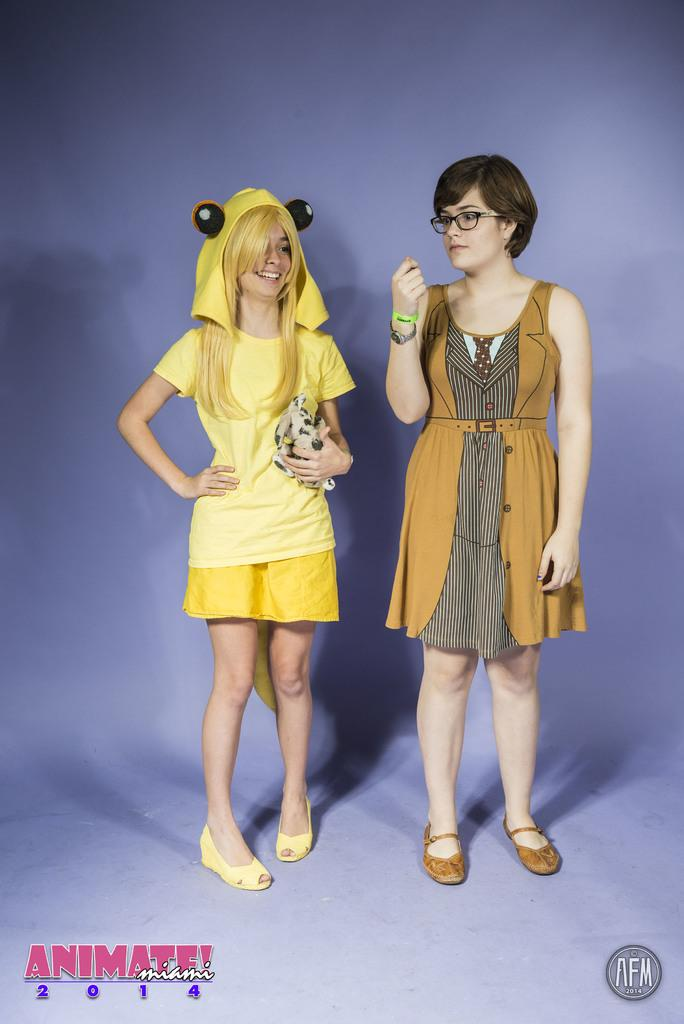How many people are in the image? There are two girls in the image. What are the girls doing in the image? Both girls are standing. Can you describe the toy that one of the girls is holding? One of the girls is holding a toy in her hand. How does the girl holding the toy appear to feel? The girl holding the toy has a smile on her face. What type of shelf can be seen in the image? There is no shelf present in the image. What connection does the girl holding the toy have with the other girl in the image? The provided facts do not mention any connection between the two girls; they are simply standing together. 